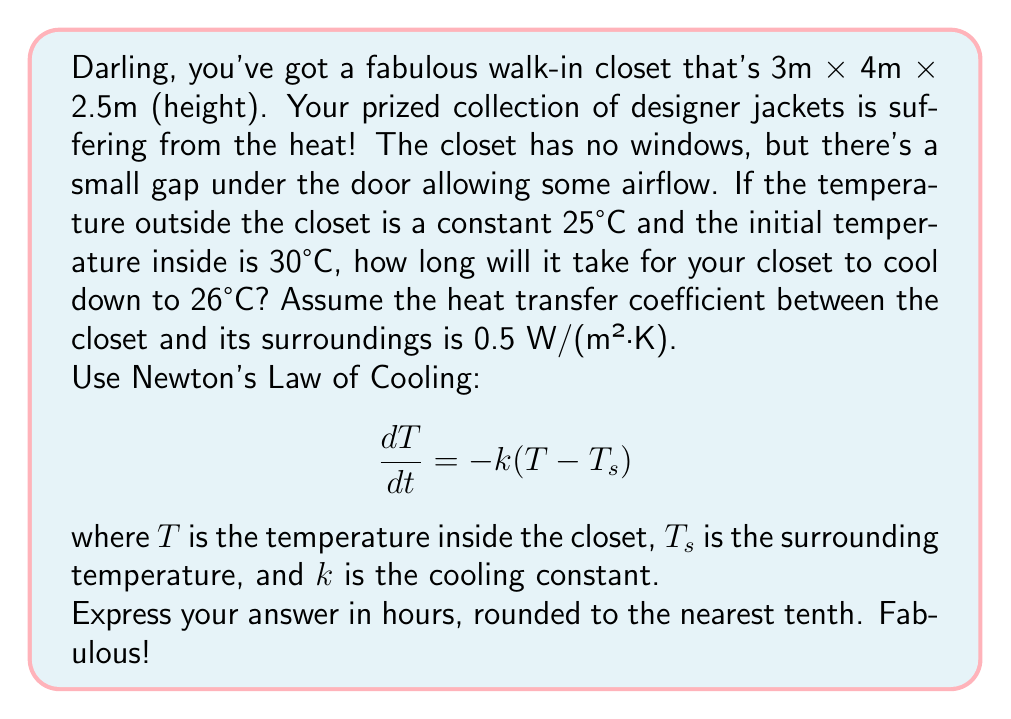Provide a solution to this math problem. Alright, fashion icon, let's break this down step-by-step:

1) First, we need to find the cooling constant $k$. It's related to the heat transfer coefficient $h$, the surface area $A$, and the thermal mass $mc_p$:

   $$k = \frac{hA}{mc_p}$$

2) The surface area of the closet is:
   $$A = 2(3 \cdot 4 + 3 \cdot 2.5 + 4 \cdot 2.5) = 55 \text{ m}^2$$

3) We don't know the exact mass or specific heat capacity, but we can use the volume of air in the closet and approximate values:
   Volume = $3 \cdot 4 \cdot 2.5 = 30 \text{ m}^3$
   Density of air ≈ 1.2 kg/m³
   Specific heat capacity of air ≈ 1000 J/(kg·K)

   So, $mc_p \approx 30 \cdot 1.2 \cdot 1000 = 36000 \text{ J/K}$

4) Now we can calculate $k$:
   $$k = \frac{0.5 \cdot 55}{36000} \approx 0.000764 \text{ s}^{-1}$$

5) The solution to Newton's Law of Cooling is:
   $$T(t) = T_s + (T_0 - T_s)e^{-kt}$$

   where $T_0$ is the initial temperature.

6) We want to find $t$ when $T(t) = 26°C$:
   
   $$26 = 25 + (30 - 25)e^{-0.000764t}$$

7) Solving for $t$:
   $$e^{-0.000764t} = \frac{1}{5}$$
   $$-0.000764t = \ln(0.2)$$
   $$t = -\frac{\ln(0.2)}{0.000764} \approx 2107 \text{ seconds}$$

8) Converting to hours:
   $$2107 \text{ seconds} \approx 0.5853 \text{ hours}$$

9) Rounding to the nearest tenth:
   $$0.6 \text{ hours}$$
Answer: 0.6 hours 